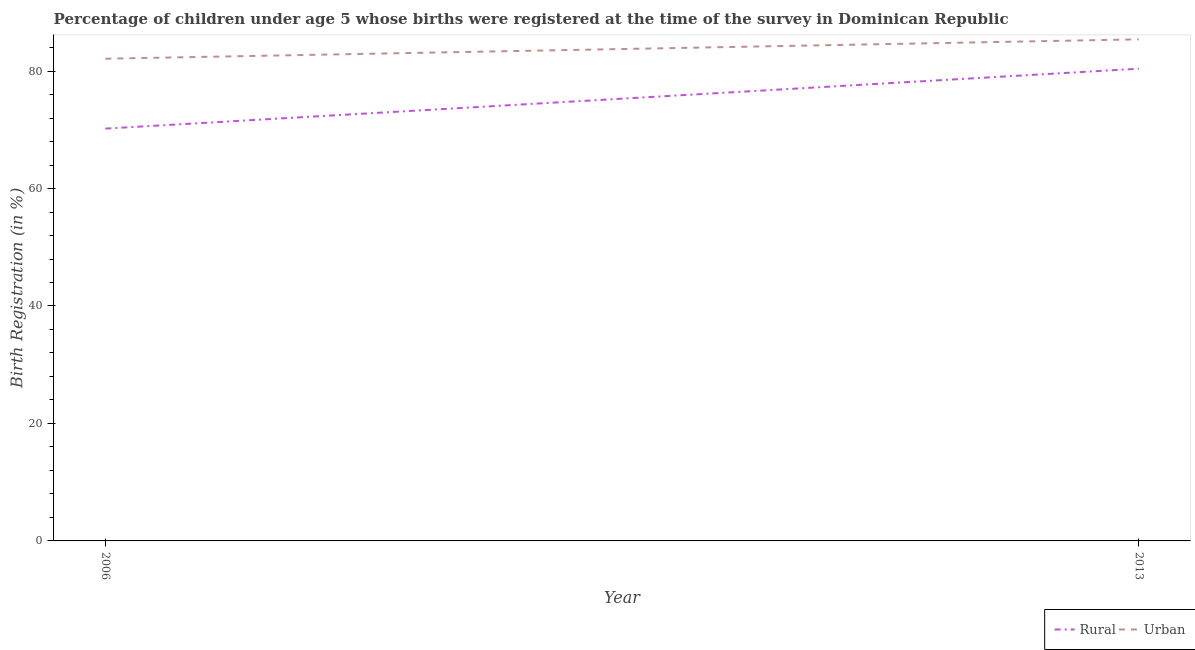What is the rural birth registration in 2013?
Your answer should be compact. 80.4. Across all years, what is the maximum urban birth registration?
Make the answer very short. 85.4. Across all years, what is the minimum rural birth registration?
Ensure brevity in your answer.  70.2. In which year was the rural birth registration maximum?
Provide a succinct answer. 2013. What is the total rural birth registration in the graph?
Your answer should be compact. 150.6. What is the difference between the rural birth registration in 2006 and that in 2013?
Give a very brief answer. -10.2. What is the difference between the urban birth registration in 2013 and the rural birth registration in 2006?
Provide a succinct answer. 15.2. What is the average urban birth registration per year?
Your response must be concise. 83.75. In how many years, is the rural birth registration greater than 76 %?
Your answer should be compact. 1. What is the ratio of the rural birth registration in 2006 to that in 2013?
Provide a short and direct response. 0.87. In how many years, is the urban birth registration greater than the average urban birth registration taken over all years?
Ensure brevity in your answer.  1. Is the urban birth registration strictly less than the rural birth registration over the years?
Your answer should be very brief. No. How many lines are there?
Keep it short and to the point. 2. What is the difference between two consecutive major ticks on the Y-axis?
Your answer should be compact. 20. Are the values on the major ticks of Y-axis written in scientific E-notation?
Offer a very short reply. No. Does the graph contain any zero values?
Your response must be concise. No. How are the legend labels stacked?
Your response must be concise. Horizontal. What is the title of the graph?
Keep it short and to the point. Percentage of children under age 5 whose births were registered at the time of the survey in Dominican Republic. Does "Secondary Education" appear as one of the legend labels in the graph?
Your response must be concise. No. What is the label or title of the Y-axis?
Give a very brief answer. Birth Registration (in %). What is the Birth Registration (in %) of Rural in 2006?
Provide a short and direct response. 70.2. What is the Birth Registration (in %) in Urban in 2006?
Your answer should be compact. 82.1. What is the Birth Registration (in %) of Rural in 2013?
Offer a terse response. 80.4. What is the Birth Registration (in %) in Urban in 2013?
Your response must be concise. 85.4. Across all years, what is the maximum Birth Registration (in %) in Rural?
Your answer should be very brief. 80.4. Across all years, what is the maximum Birth Registration (in %) of Urban?
Ensure brevity in your answer.  85.4. Across all years, what is the minimum Birth Registration (in %) in Rural?
Keep it short and to the point. 70.2. Across all years, what is the minimum Birth Registration (in %) of Urban?
Provide a succinct answer. 82.1. What is the total Birth Registration (in %) of Rural in the graph?
Provide a short and direct response. 150.6. What is the total Birth Registration (in %) of Urban in the graph?
Your response must be concise. 167.5. What is the difference between the Birth Registration (in %) of Rural in 2006 and that in 2013?
Provide a short and direct response. -10.2. What is the difference between the Birth Registration (in %) of Urban in 2006 and that in 2013?
Your response must be concise. -3.3. What is the difference between the Birth Registration (in %) of Rural in 2006 and the Birth Registration (in %) of Urban in 2013?
Keep it short and to the point. -15.2. What is the average Birth Registration (in %) of Rural per year?
Give a very brief answer. 75.3. What is the average Birth Registration (in %) of Urban per year?
Your answer should be compact. 83.75. In the year 2006, what is the difference between the Birth Registration (in %) of Rural and Birth Registration (in %) of Urban?
Offer a terse response. -11.9. In the year 2013, what is the difference between the Birth Registration (in %) of Rural and Birth Registration (in %) of Urban?
Your answer should be compact. -5. What is the ratio of the Birth Registration (in %) of Rural in 2006 to that in 2013?
Offer a very short reply. 0.87. What is the ratio of the Birth Registration (in %) in Urban in 2006 to that in 2013?
Offer a very short reply. 0.96. What is the difference between the highest and the second highest Birth Registration (in %) of Rural?
Your answer should be compact. 10.2. What is the difference between the highest and the second highest Birth Registration (in %) in Urban?
Your answer should be very brief. 3.3. What is the difference between the highest and the lowest Birth Registration (in %) in Rural?
Your response must be concise. 10.2. What is the difference between the highest and the lowest Birth Registration (in %) of Urban?
Your answer should be compact. 3.3. 